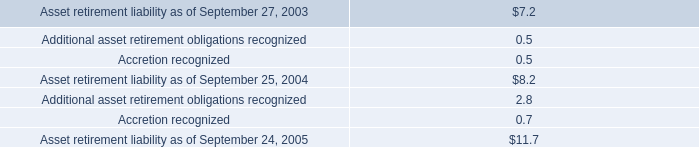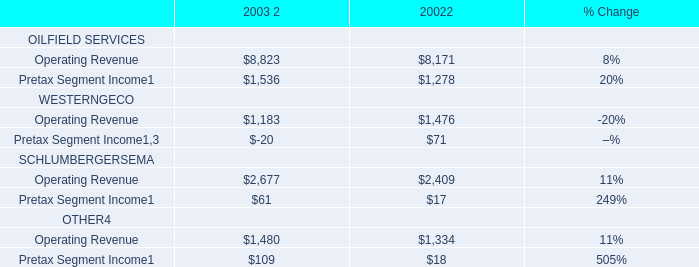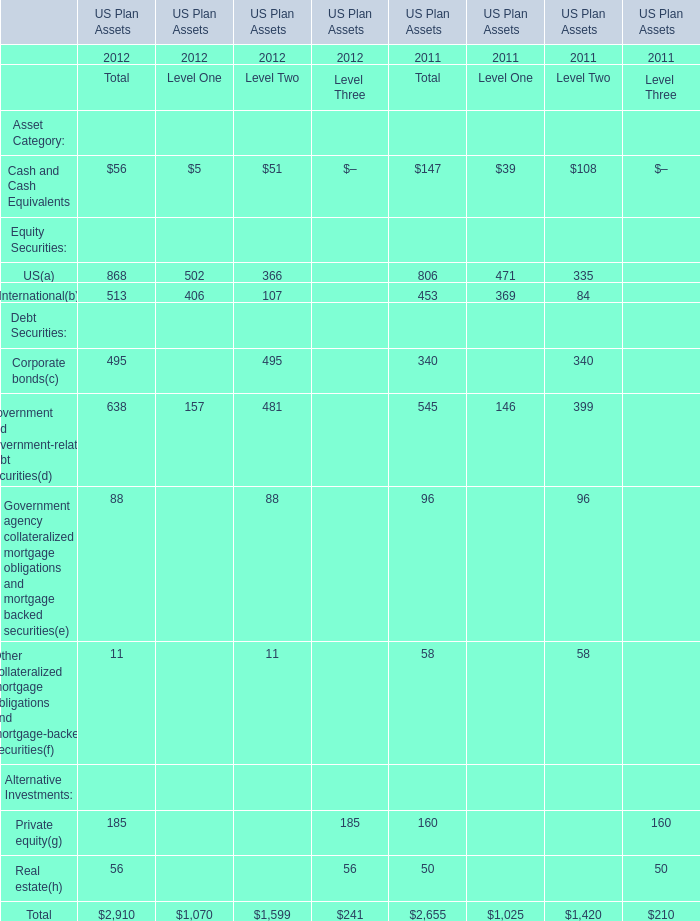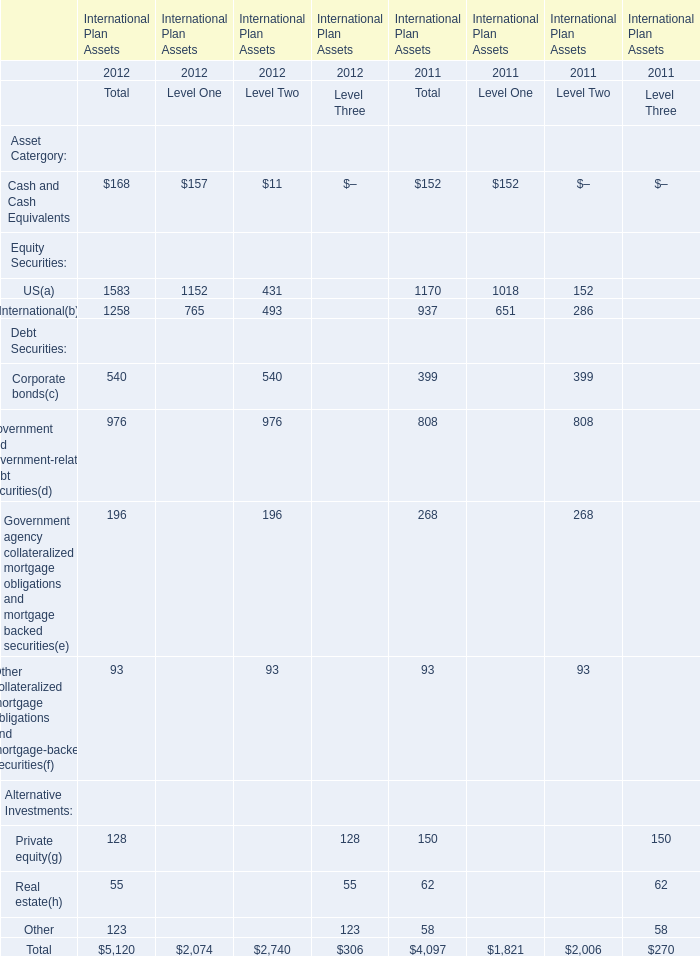What is the sum of International in the range of 1 and 1000 in 2012 ? 
Computations: ((513 + 406) + 107)
Answer: 1026.0. 